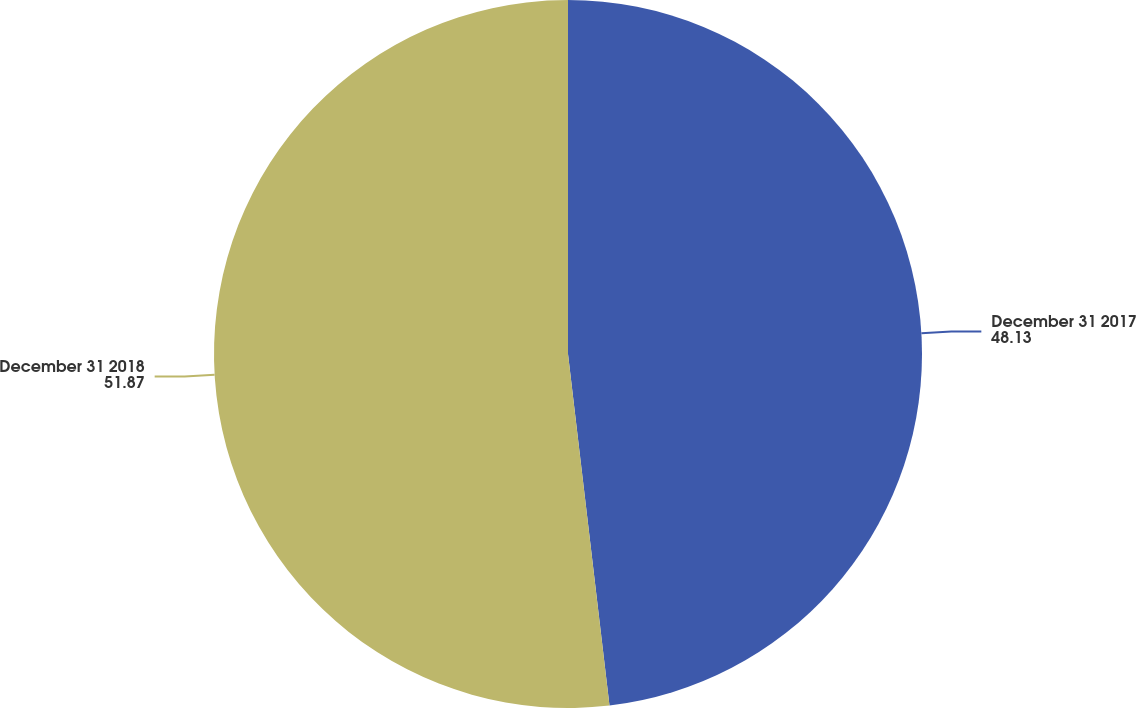Convert chart. <chart><loc_0><loc_0><loc_500><loc_500><pie_chart><fcel>December 31 2017<fcel>December 31 2018<nl><fcel>48.13%<fcel>51.87%<nl></chart> 